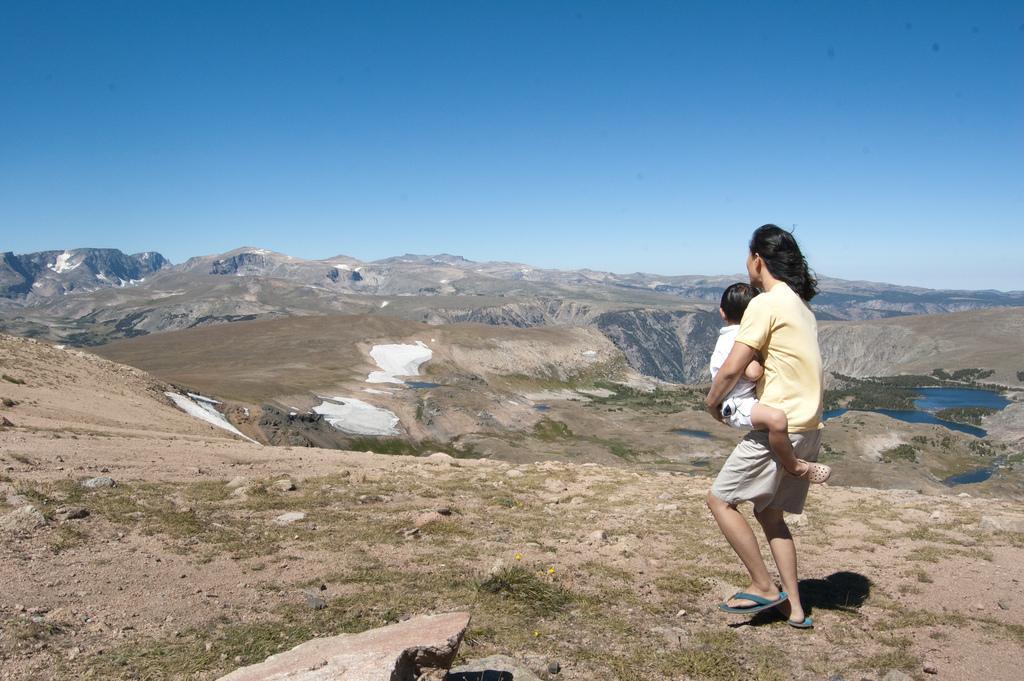Describe this image in one or two sentences. In this image we can see a person carrying a kid, there are some rocks, grass, mountains, water, also we can see the sky. 